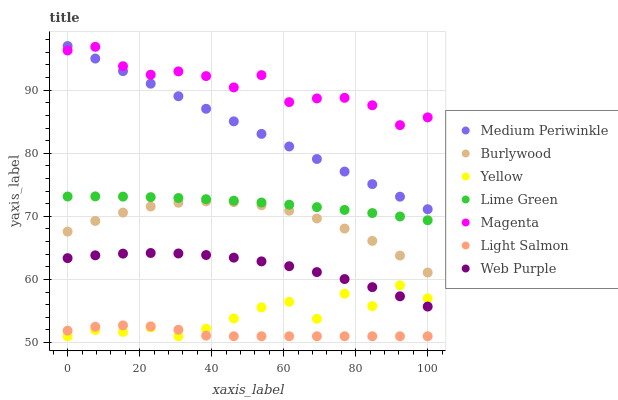Does Light Salmon have the minimum area under the curve?
Answer yes or no. Yes. Does Magenta have the maximum area under the curve?
Answer yes or no. Yes. Does Burlywood have the minimum area under the curve?
Answer yes or no. No. Does Burlywood have the maximum area under the curve?
Answer yes or no. No. Is Medium Periwinkle the smoothest?
Answer yes or no. Yes. Is Yellow the roughest?
Answer yes or no. Yes. Is Burlywood the smoothest?
Answer yes or no. No. Is Burlywood the roughest?
Answer yes or no. No. Does Light Salmon have the lowest value?
Answer yes or no. Yes. Does Burlywood have the lowest value?
Answer yes or no. No. Does Medium Periwinkle have the highest value?
Answer yes or no. Yes. Does Burlywood have the highest value?
Answer yes or no. No. Is Yellow less than Magenta?
Answer yes or no. Yes. Is Medium Periwinkle greater than Web Purple?
Answer yes or no. Yes. Does Web Purple intersect Yellow?
Answer yes or no. Yes. Is Web Purple less than Yellow?
Answer yes or no. No. Is Web Purple greater than Yellow?
Answer yes or no. No. Does Yellow intersect Magenta?
Answer yes or no. No. 